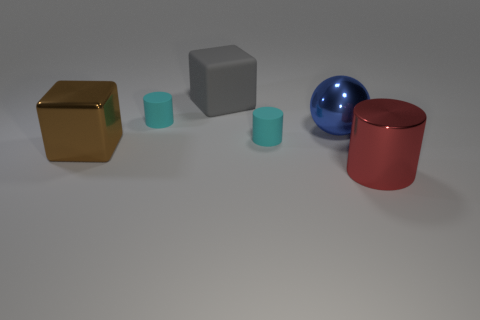Do the cyan matte thing on the left side of the gray matte thing and the gray cube have the same size? No, the cyan matte cylinder on the left of the gray cube does not have the same size. The cyan cylinder is shorter in height, but seems to have a similar diameter when compared to the gray cube's dimensions. 